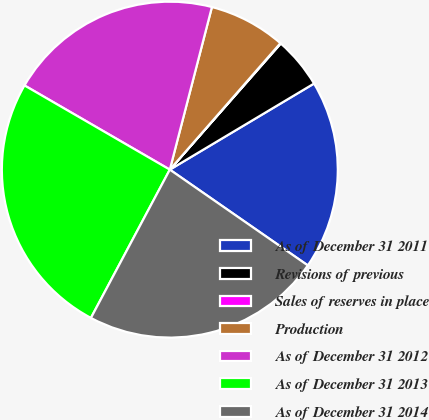<chart> <loc_0><loc_0><loc_500><loc_500><pie_chart><fcel>As of December 31 2011<fcel>Revisions of previous<fcel>Sales of reserves in place<fcel>Production<fcel>As of December 31 2012<fcel>As of December 31 2013<fcel>As of December 31 2014<nl><fcel>18.22%<fcel>4.95%<fcel>0.05%<fcel>7.4%<fcel>20.67%<fcel>25.57%<fcel>23.12%<nl></chart> 